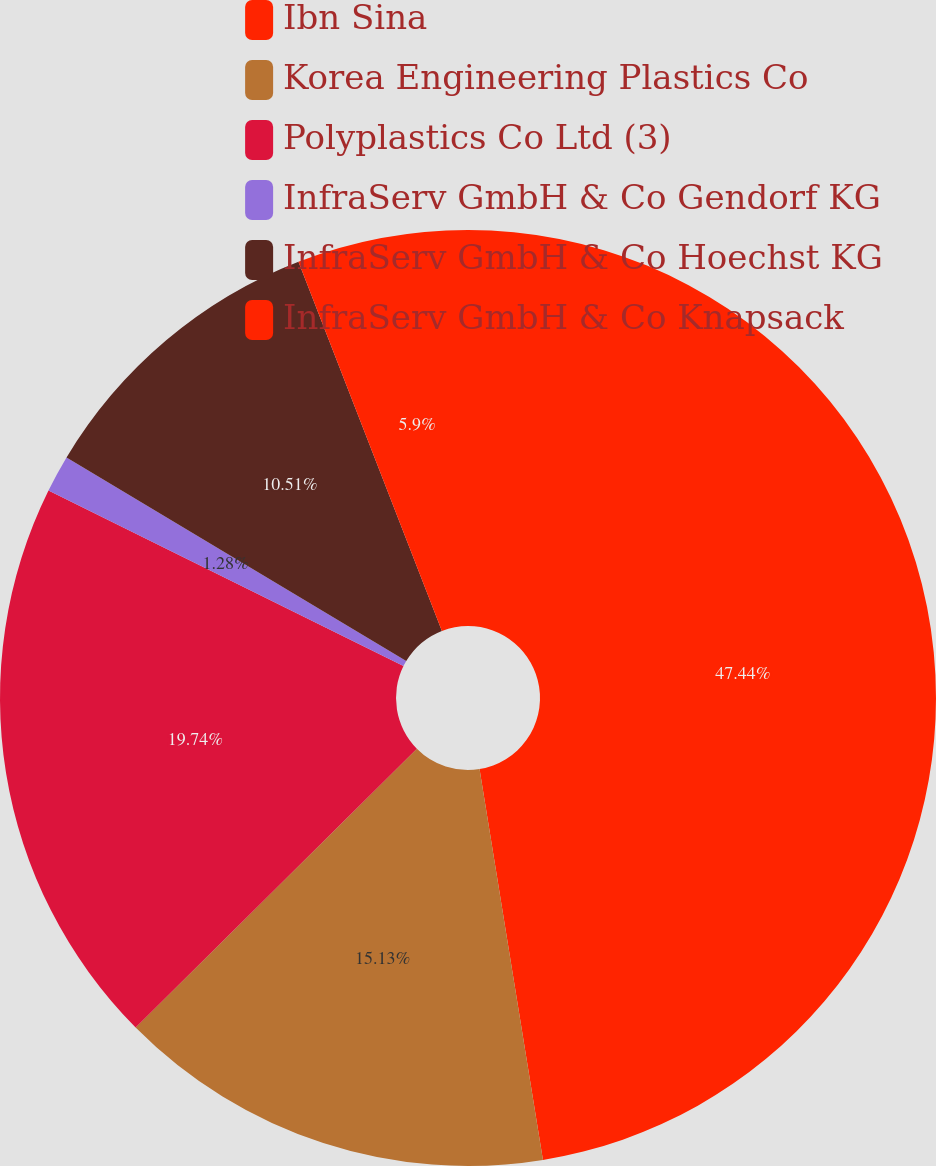<chart> <loc_0><loc_0><loc_500><loc_500><pie_chart><fcel>Ibn Sina<fcel>Korea Engineering Plastics Co<fcel>Polyplastics Co Ltd (3)<fcel>InfraServ GmbH & Co Gendorf KG<fcel>InfraServ GmbH & Co Hoechst KG<fcel>InfraServ GmbH & Co Knapsack<nl><fcel>47.44%<fcel>15.13%<fcel>19.74%<fcel>1.28%<fcel>10.51%<fcel>5.9%<nl></chart> 